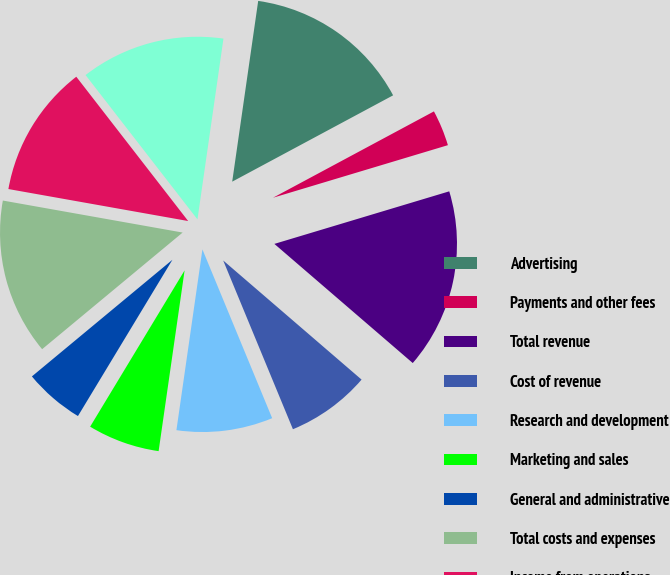<chart> <loc_0><loc_0><loc_500><loc_500><pie_chart><fcel>Advertising<fcel>Payments and other fees<fcel>Total revenue<fcel>Cost of revenue<fcel>Research and development<fcel>Marketing and sales<fcel>General and administrative<fcel>Total costs and expenses<fcel>Income from operations<fcel>Income before provision for<nl><fcel>14.89%<fcel>3.19%<fcel>15.96%<fcel>7.45%<fcel>8.51%<fcel>6.38%<fcel>5.32%<fcel>13.83%<fcel>11.7%<fcel>12.77%<nl></chart> 